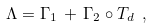Convert formula to latex. <formula><loc_0><loc_0><loc_500><loc_500>\Lambda = \Gamma _ { 1 } \, + \, \Gamma _ { 2 } \circ T _ { d } \ ,</formula> 